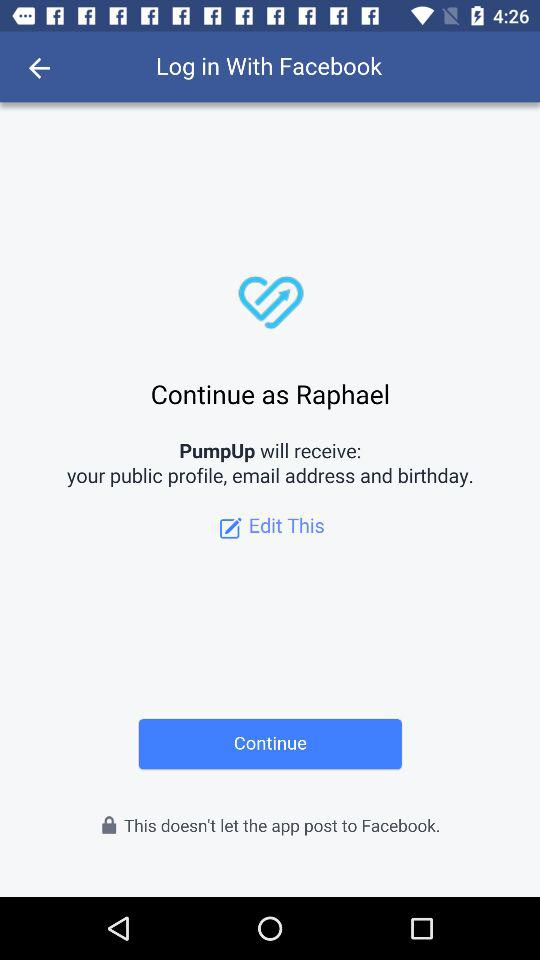What is the login name? The login name is Raphael. 